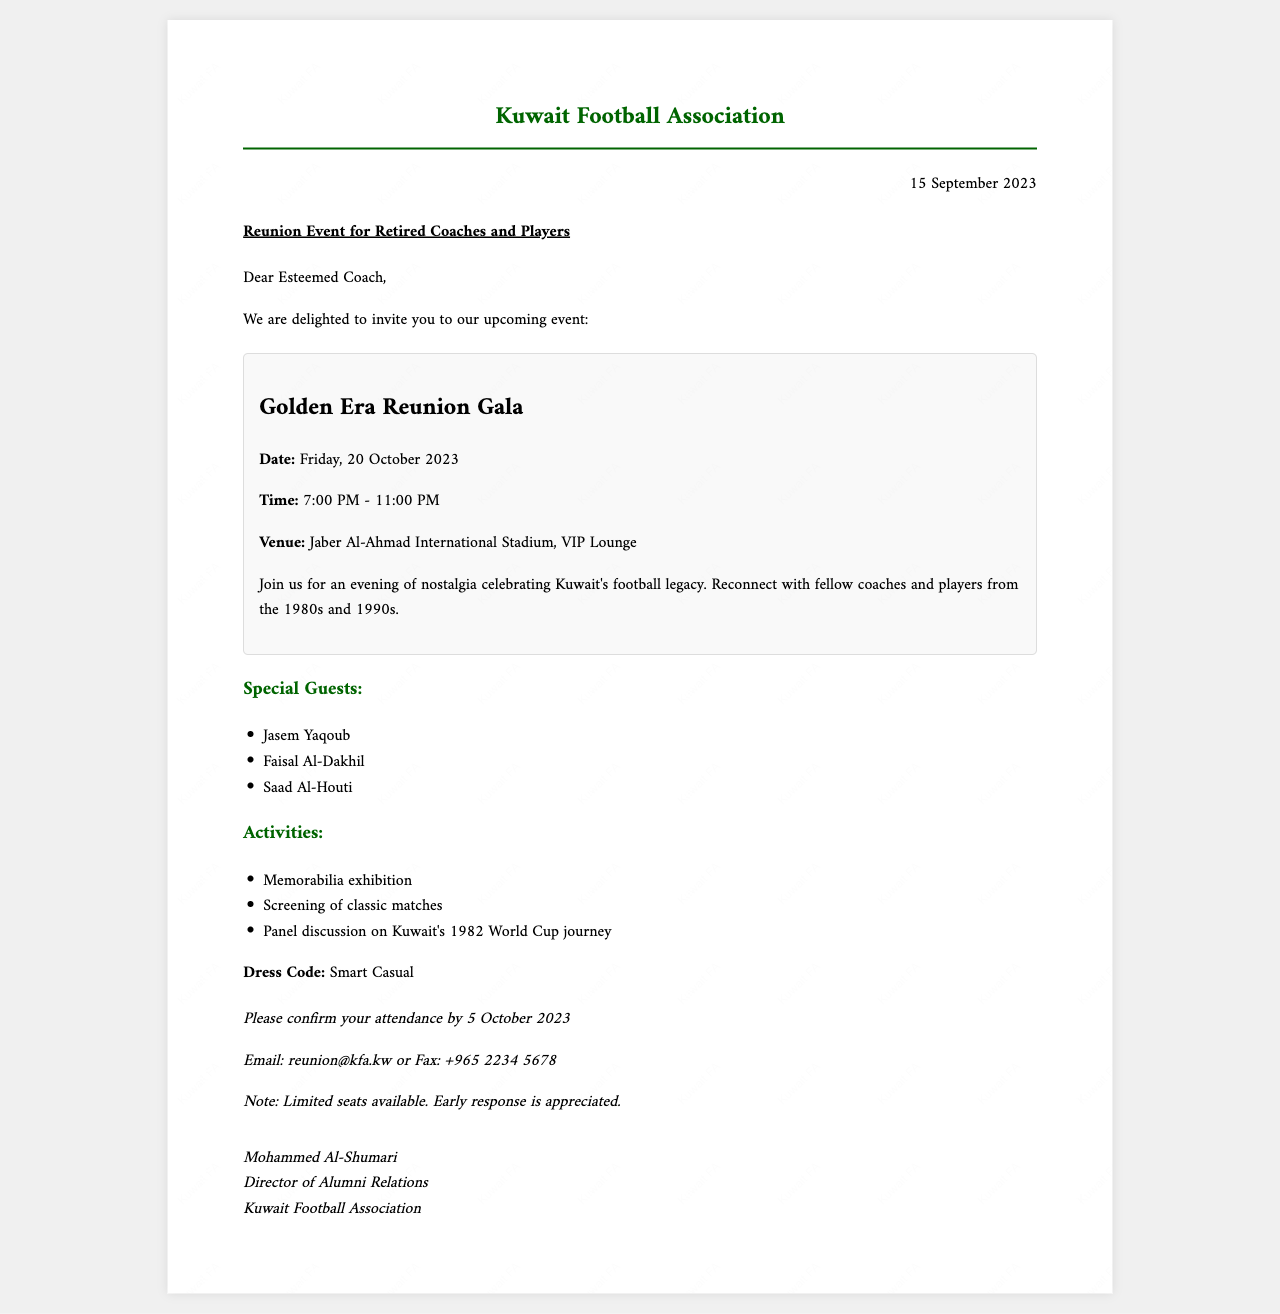What is the event called? The event is referred to as the "Golden Era Reunion Gala" in the document.
Answer: Golden Era Reunion Gala What is the date of the reunion event? The event is scheduled for "Friday, 20 October 2023" as stated in the document.
Answer: Friday, 20 October 2023 What time does the event start? The event begins at "7:00 PM" as indicated in the event details section.
Answer: 7:00 PM Who is one of the special guests? The document lists notable individuals, one of whom is "Jasem Yaqoub."
Answer: Jasem Yaqoub What is the RSVP deadline? Attendees are asked to confirm attendance by "5 October 2023" according to the RSVP instructions.
Answer: 5 October 2023 What is the dress code for the event? The document specifies the dress code as "Smart Casual."
Answer: Smart Casual How can one confirm their attendance? The document states attendance can be confirmed via "Email: reunion@kfa.kw or Fax: +965 2234 5678."
Answer: Email: reunion@kfa.kw or Fax: +965 2234 5678 What kind of activities will take place at the event? The event will feature a "Memorabilia exhibition," a "Screening of classic matches," and a "Panel discussion on Kuwait's 1982 World Cup journey."
Answer: Memorabilia exhibition, Screening of classic matches, Panel discussion on Kuwait's 1982 World Cup journey 